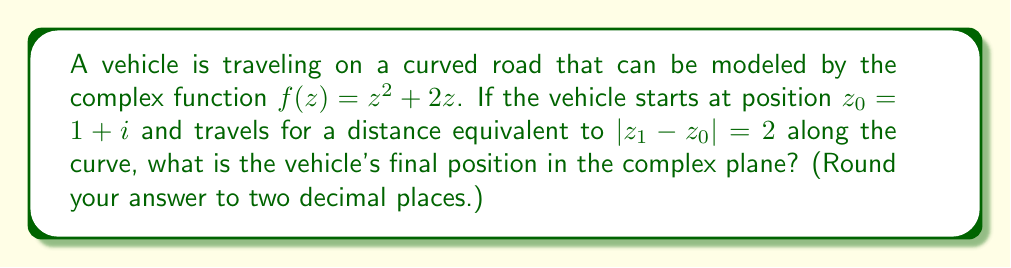Teach me how to tackle this problem. To solve this problem, we'll follow these steps:

1) The curve is given by $f(z) = z^2 + 2z$. We need to find $z_1$ such that $|z_1 - z_0| = 2$.

2) We can parametrize the curve using a real parameter $t$:
   $z(t) = t + i(t^2 + t)$

3) The starting point $z_0 = 1+i$ corresponds to $t=1$.

4) To find $z_1$, we need to integrate the arc length:

   $$s = \int_1^t \sqrt{1 + |z'(\tau)|^2} d\tau = \int_1^t \sqrt{1 + (2\tau + 1)^2} d\tau = 2$$

5) This integral doesn't have a simple closed form. We can solve it numerically to find $t \approx 1.6234$.

6) Substituting this value back into our parametrization:

   $z_1 \approx 1.6234 + i(1.6234^2 + 1.6234) \approx 1.62 + 3.26i$

7) We can verify: $|z_1 - z_0| = |(1.62 + 3.26i) - (1 + i)| \approx 2$

8) The final position of the vehicle is approximately $1.62 + 3.26i$.
Answer: $1.62 + 3.26i$ 